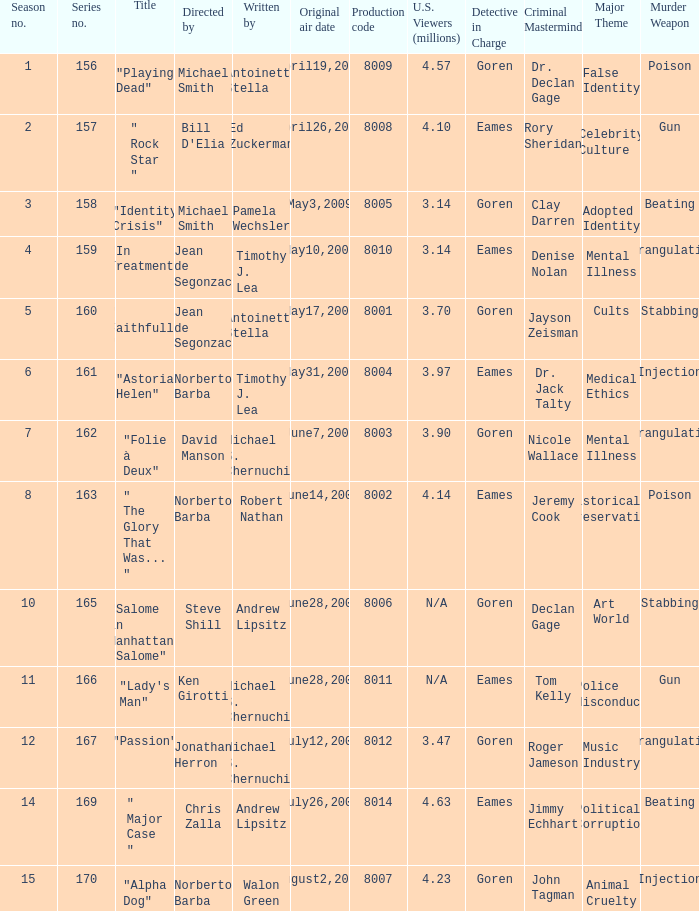How many writers write the episode whose director is Jonathan Herron? 1.0. Could you parse the entire table? {'header': ['Season no.', 'Series no.', 'Title', 'Directed by', 'Written by', 'Original air date', 'Production code', 'U.S. Viewers (millions)', 'Detective in Charge', 'Criminal Mastermind', 'Major Theme', 'Murder Weapon'], 'rows': [['1', '156', '"Playing Dead"', 'Michael Smith', 'Antoinette Stella', 'April19,2009', '8009', '4.57', 'Goren', 'Dr. Declan Gage', 'False Identity', 'Poison'], ['2', '157', '" Rock Star "', "Bill D'Elia", 'Ed Zuckerman', 'April26,2009', '8008', '4.10', 'Eames', 'Rory Sheridan', 'Celebrity Culture', 'Gun'], ['3', '158', '"Identity Crisis"', 'Michael Smith', 'Pamela Wechsler', 'May3,2009', '8005', '3.14', 'Goren', 'Clay Darren', 'Adopted Identity', 'Beating'], ['4', '159', '"In Treatment"', 'Jean de Segonzac', 'Timothy J. Lea', 'May10,2009', '8010', '3.14', 'Eames', 'Denise Nolan', 'Mental Illness', 'Strangulation'], ['5', '160', '" Faithfully "', 'Jean de Segonzac', 'Antoinette Stella', 'May17,2009', '8001', '3.70', 'Goren', 'Jayson Zeisman', 'Cults', 'Stabbing'], ['6', '161', '"Astoria Helen"', 'Norberto Barba', 'Timothy J. Lea', 'May31,2009', '8004', '3.97', 'Eames', 'Dr. Jack Talty', 'Medical Ethics', 'Injection'], ['7', '162', '"Folie à Deux"', 'David Manson', 'Michael S. Chernuchin', 'June7,2009', '8003', '3.90', 'Goren', 'Nicole Wallace', 'Mental Illness', 'Strangulation'], ['8', '163', '" The Glory That Was... "', 'Norberto Barba', 'Robert Nathan', 'June14,2009', '8002', '4.14', 'Eames', 'Jeremy Cook', 'Historical Preservation', 'Poison'], ['10', '165', '"Salome in Manhattan" "Salome"', 'Steve Shill', 'Andrew Lipsitz', 'June28,2009', '8006', 'N/A', 'Goren', 'Declan Gage', 'Art World', 'Stabbing'], ['11', '166', '"Lady\'s Man"', 'Ken Girotti', 'Michael S. Chernuchin', 'June28,2009', '8011', 'N/A', 'Eames', 'Tom Kelly', 'Police Misconduct', 'Gun'], ['12', '167', '"Passion"', 'Jonathan Herron', 'Michael S. Chernuchin', 'July12,2009', '8012', '3.47', 'Goren', 'Roger Jameson', 'Music Industry', 'Strangulation'], ['14', '169', '" Major Case "', 'Chris Zalla', 'Andrew Lipsitz', 'July26,2009', '8014', '4.63', 'Eames', 'Jimmy Echhart', 'Political Corruption', 'Beating'], ['15', '170', '"Alpha Dog"', 'Norberto Barba', 'Walon Green', 'August2,2009', '8007', '4.23', 'Goren', 'John Tagman', 'Animal Cruelty', 'Injection']]} 